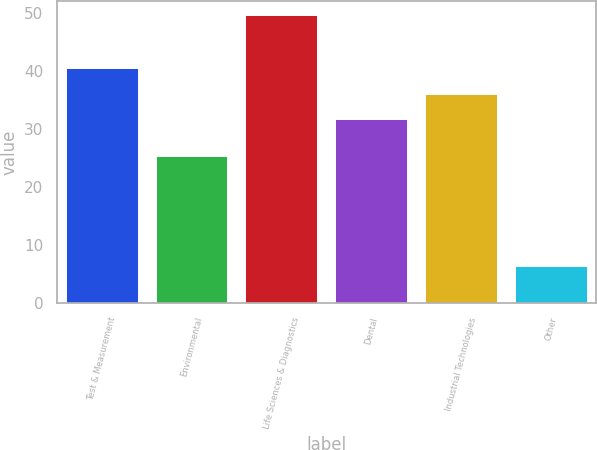Convert chart to OTSL. <chart><loc_0><loc_0><loc_500><loc_500><bar_chart><fcel>Test & Measurement<fcel>Environmental<fcel>Life Sciences & Diagnostics<fcel>Dental<fcel>Industrial Technologies<fcel>Other<nl><fcel>40.44<fcel>25.4<fcel>49.6<fcel>31.8<fcel>36.12<fcel>6.4<nl></chart> 